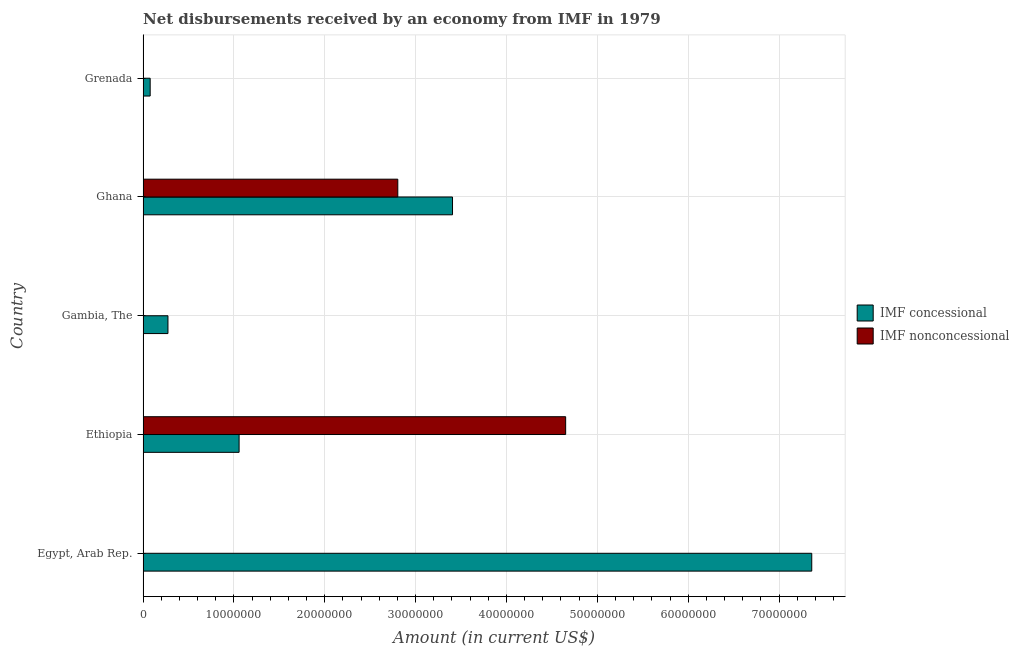Are the number of bars per tick equal to the number of legend labels?
Make the answer very short. No. Are the number of bars on each tick of the Y-axis equal?
Your answer should be compact. No. How many bars are there on the 4th tick from the top?
Provide a succinct answer. 2. What is the label of the 3rd group of bars from the top?
Your answer should be very brief. Gambia, The. In how many cases, is the number of bars for a given country not equal to the number of legend labels?
Keep it short and to the point. 3. Across all countries, what is the maximum net concessional disbursements from imf?
Offer a very short reply. 7.36e+07. Across all countries, what is the minimum net concessional disbursements from imf?
Provide a succinct answer. 7.83e+05. In which country was the net non concessional disbursements from imf maximum?
Make the answer very short. Ethiopia. What is the total net concessional disbursements from imf in the graph?
Your answer should be very brief. 1.22e+08. What is the difference between the net non concessional disbursements from imf in Ethiopia and that in Ghana?
Provide a succinct answer. 1.85e+07. What is the difference between the net concessional disbursements from imf in Grenada and the net non concessional disbursements from imf in Ethiopia?
Provide a succinct answer. -4.57e+07. What is the average net concessional disbursements from imf per country?
Provide a short and direct response. 2.44e+07. What is the difference between the net concessional disbursements from imf and net non concessional disbursements from imf in Ethiopia?
Provide a short and direct response. -3.59e+07. What is the ratio of the net concessional disbursements from imf in Egypt, Arab Rep. to that in Gambia, The?
Your response must be concise. 26.86. Is the net concessional disbursements from imf in Ethiopia less than that in Gambia, The?
Provide a succinct answer. No. What is the difference between the highest and the second highest net concessional disbursements from imf?
Your answer should be compact. 3.95e+07. What is the difference between the highest and the lowest net non concessional disbursements from imf?
Ensure brevity in your answer.  4.65e+07. How many bars are there?
Provide a short and direct response. 7. Are all the bars in the graph horizontal?
Offer a very short reply. Yes. How many countries are there in the graph?
Provide a succinct answer. 5. Are the values on the major ticks of X-axis written in scientific E-notation?
Keep it short and to the point. No. Does the graph contain any zero values?
Your response must be concise. Yes. Where does the legend appear in the graph?
Provide a succinct answer. Center right. How many legend labels are there?
Your answer should be compact. 2. What is the title of the graph?
Your response must be concise. Net disbursements received by an economy from IMF in 1979. Does "Nitrous oxide emissions" appear as one of the legend labels in the graph?
Give a very brief answer. No. What is the label or title of the X-axis?
Provide a short and direct response. Amount (in current US$). What is the label or title of the Y-axis?
Your answer should be compact. Country. What is the Amount (in current US$) in IMF concessional in Egypt, Arab Rep.?
Provide a succinct answer. 7.36e+07. What is the Amount (in current US$) in IMF nonconcessional in Egypt, Arab Rep.?
Ensure brevity in your answer.  0. What is the Amount (in current US$) in IMF concessional in Ethiopia?
Your answer should be compact. 1.06e+07. What is the Amount (in current US$) of IMF nonconcessional in Ethiopia?
Your response must be concise. 4.65e+07. What is the Amount (in current US$) in IMF concessional in Gambia, The?
Provide a succinct answer. 2.74e+06. What is the Amount (in current US$) in IMF concessional in Ghana?
Provide a short and direct response. 3.41e+07. What is the Amount (in current US$) in IMF nonconcessional in Ghana?
Your response must be concise. 2.80e+07. What is the Amount (in current US$) of IMF concessional in Grenada?
Give a very brief answer. 7.83e+05. What is the Amount (in current US$) in IMF nonconcessional in Grenada?
Offer a very short reply. 0. Across all countries, what is the maximum Amount (in current US$) in IMF concessional?
Your response must be concise. 7.36e+07. Across all countries, what is the maximum Amount (in current US$) in IMF nonconcessional?
Offer a terse response. 4.65e+07. Across all countries, what is the minimum Amount (in current US$) in IMF concessional?
Give a very brief answer. 7.83e+05. Across all countries, what is the minimum Amount (in current US$) of IMF nonconcessional?
Provide a short and direct response. 0. What is the total Amount (in current US$) of IMF concessional in the graph?
Make the answer very short. 1.22e+08. What is the total Amount (in current US$) of IMF nonconcessional in the graph?
Offer a very short reply. 7.46e+07. What is the difference between the Amount (in current US$) in IMF concessional in Egypt, Arab Rep. and that in Ethiopia?
Provide a succinct answer. 6.30e+07. What is the difference between the Amount (in current US$) in IMF concessional in Egypt, Arab Rep. and that in Gambia, The?
Offer a very short reply. 7.09e+07. What is the difference between the Amount (in current US$) of IMF concessional in Egypt, Arab Rep. and that in Ghana?
Offer a very short reply. 3.95e+07. What is the difference between the Amount (in current US$) in IMF concessional in Egypt, Arab Rep. and that in Grenada?
Make the answer very short. 7.28e+07. What is the difference between the Amount (in current US$) in IMF concessional in Ethiopia and that in Gambia, The?
Ensure brevity in your answer.  7.83e+06. What is the difference between the Amount (in current US$) in IMF concessional in Ethiopia and that in Ghana?
Your response must be concise. -2.35e+07. What is the difference between the Amount (in current US$) in IMF nonconcessional in Ethiopia and that in Ghana?
Provide a short and direct response. 1.85e+07. What is the difference between the Amount (in current US$) of IMF concessional in Ethiopia and that in Grenada?
Ensure brevity in your answer.  9.79e+06. What is the difference between the Amount (in current US$) in IMF concessional in Gambia, The and that in Ghana?
Your answer should be very brief. -3.13e+07. What is the difference between the Amount (in current US$) of IMF concessional in Gambia, The and that in Grenada?
Offer a terse response. 1.96e+06. What is the difference between the Amount (in current US$) in IMF concessional in Ghana and that in Grenada?
Your answer should be compact. 3.33e+07. What is the difference between the Amount (in current US$) in IMF concessional in Egypt, Arab Rep. and the Amount (in current US$) in IMF nonconcessional in Ethiopia?
Make the answer very short. 2.71e+07. What is the difference between the Amount (in current US$) in IMF concessional in Egypt, Arab Rep. and the Amount (in current US$) in IMF nonconcessional in Ghana?
Offer a very short reply. 4.56e+07. What is the difference between the Amount (in current US$) of IMF concessional in Ethiopia and the Amount (in current US$) of IMF nonconcessional in Ghana?
Offer a terse response. -1.75e+07. What is the difference between the Amount (in current US$) in IMF concessional in Gambia, The and the Amount (in current US$) in IMF nonconcessional in Ghana?
Keep it short and to the point. -2.53e+07. What is the average Amount (in current US$) in IMF concessional per country?
Your response must be concise. 2.44e+07. What is the average Amount (in current US$) of IMF nonconcessional per country?
Offer a terse response. 1.49e+07. What is the difference between the Amount (in current US$) in IMF concessional and Amount (in current US$) in IMF nonconcessional in Ethiopia?
Provide a short and direct response. -3.59e+07. What is the difference between the Amount (in current US$) of IMF concessional and Amount (in current US$) of IMF nonconcessional in Ghana?
Make the answer very short. 6.02e+06. What is the ratio of the Amount (in current US$) of IMF concessional in Egypt, Arab Rep. to that in Ethiopia?
Make the answer very short. 6.96. What is the ratio of the Amount (in current US$) of IMF concessional in Egypt, Arab Rep. to that in Gambia, The?
Provide a short and direct response. 26.86. What is the ratio of the Amount (in current US$) in IMF concessional in Egypt, Arab Rep. to that in Ghana?
Provide a succinct answer. 2.16. What is the ratio of the Amount (in current US$) of IMF concessional in Egypt, Arab Rep. to that in Grenada?
Give a very brief answer. 94. What is the ratio of the Amount (in current US$) of IMF concessional in Ethiopia to that in Gambia, The?
Offer a terse response. 3.86. What is the ratio of the Amount (in current US$) in IMF concessional in Ethiopia to that in Ghana?
Provide a short and direct response. 0.31. What is the ratio of the Amount (in current US$) of IMF nonconcessional in Ethiopia to that in Ghana?
Give a very brief answer. 1.66. What is the ratio of the Amount (in current US$) of IMF concessional in Ethiopia to that in Grenada?
Ensure brevity in your answer.  13.5. What is the ratio of the Amount (in current US$) in IMF concessional in Gambia, The to that in Ghana?
Give a very brief answer. 0.08. What is the ratio of the Amount (in current US$) of IMF concessional in Gambia, The to that in Grenada?
Offer a terse response. 3.5. What is the ratio of the Amount (in current US$) of IMF concessional in Ghana to that in Grenada?
Provide a succinct answer. 43.5. What is the difference between the highest and the second highest Amount (in current US$) in IMF concessional?
Ensure brevity in your answer.  3.95e+07. What is the difference between the highest and the lowest Amount (in current US$) in IMF concessional?
Ensure brevity in your answer.  7.28e+07. What is the difference between the highest and the lowest Amount (in current US$) of IMF nonconcessional?
Your answer should be compact. 4.65e+07. 